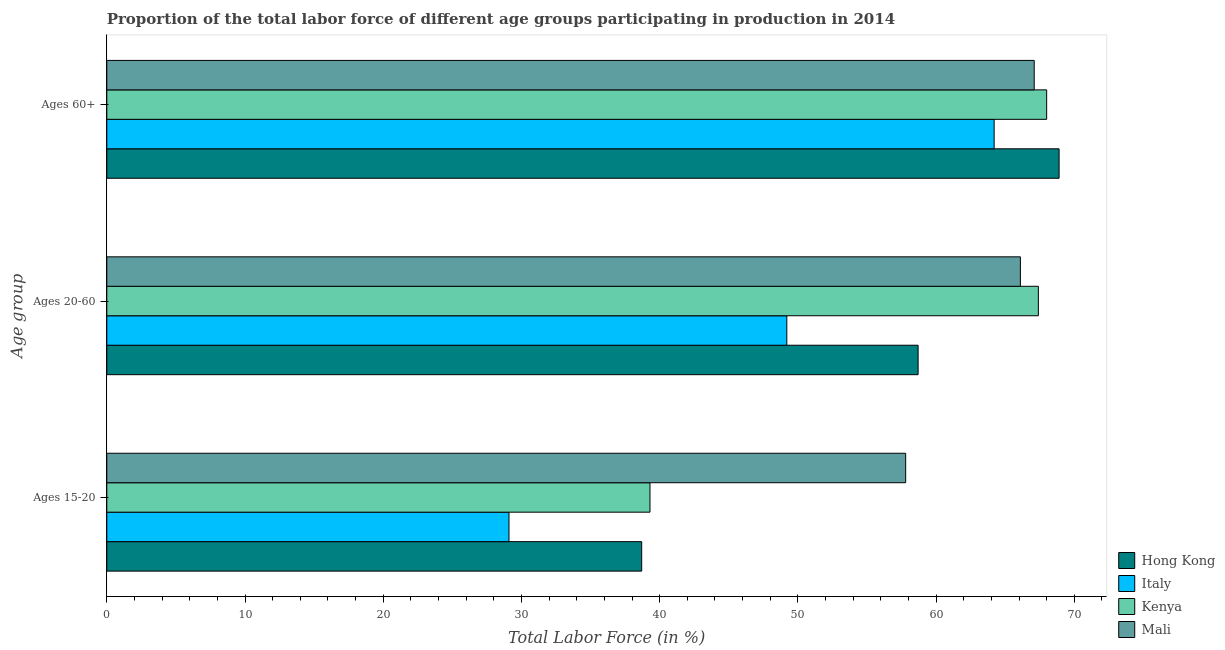How many different coloured bars are there?
Offer a very short reply. 4. How many groups of bars are there?
Your answer should be very brief. 3. Are the number of bars per tick equal to the number of legend labels?
Ensure brevity in your answer.  Yes. How many bars are there on the 2nd tick from the top?
Give a very brief answer. 4. How many bars are there on the 3rd tick from the bottom?
Your answer should be compact. 4. What is the label of the 2nd group of bars from the top?
Your answer should be very brief. Ages 20-60. What is the percentage of labor force within the age group 20-60 in Mali?
Your answer should be compact. 66.1. Across all countries, what is the maximum percentage of labor force within the age group 20-60?
Make the answer very short. 67.4. Across all countries, what is the minimum percentage of labor force above age 60?
Ensure brevity in your answer.  64.2. In which country was the percentage of labor force within the age group 20-60 maximum?
Offer a very short reply. Kenya. In which country was the percentage of labor force above age 60 minimum?
Provide a succinct answer. Italy. What is the total percentage of labor force above age 60 in the graph?
Your answer should be very brief. 268.2. What is the difference between the percentage of labor force within the age group 20-60 in Kenya and that in Italy?
Your answer should be very brief. 18.2. What is the difference between the percentage of labor force above age 60 in Mali and the percentage of labor force within the age group 15-20 in Kenya?
Offer a very short reply. 27.8. What is the average percentage of labor force above age 60 per country?
Your answer should be compact. 67.05. What is the difference between the percentage of labor force within the age group 15-20 and percentage of labor force within the age group 20-60 in Mali?
Keep it short and to the point. -8.3. In how many countries, is the percentage of labor force within the age group 20-60 greater than 4 %?
Your answer should be very brief. 4. What is the ratio of the percentage of labor force within the age group 20-60 in Mali to that in Kenya?
Provide a succinct answer. 0.98. Is the percentage of labor force within the age group 20-60 in Hong Kong less than that in Mali?
Your answer should be very brief. Yes. Is the difference between the percentage of labor force within the age group 15-20 in Hong Kong and Italy greater than the difference between the percentage of labor force above age 60 in Hong Kong and Italy?
Make the answer very short. Yes. What is the difference between the highest and the second highest percentage of labor force above age 60?
Provide a short and direct response. 0.9. What is the difference between the highest and the lowest percentage of labor force above age 60?
Offer a very short reply. 4.7. In how many countries, is the percentage of labor force within the age group 15-20 greater than the average percentage of labor force within the age group 15-20 taken over all countries?
Ensure brevity in your answer.  1. Is the sum of the percentage of labor force above age 60 in Mali and Hong Kong greater than the maximum percentage of labor force within the age group 20-60 across all countries?
Ensure brevity in your answer.  Yes. What does the 1st bar from the bottom in Ages 60+ represents?
Provide a short and direct response. Hong Kong. How many bars are there?
Make the answer very short. 12. Are all the bars in the graph horizontal?
Give a very brief answer. Yes. How many countries are there in the graph?
Provide a succinct answer. 4. Does the graph contain grids?
Ensure brevity in your answer.  No. How many legend labels are there?
Your response must be concise. 4. What is the title of the graph?
Provide a succinct answer. Proportion of the total labor force of different age groups participating in production in 2014. What is the label or title of the X-axis?
Your response must be concise. Total Labor Force (in %). What is the label or title of the Y-axis?
Ensure brevity in your answer.  Age group. What is the Total Labor Force (in %) in Hong Kong in Ages 15-20?
Offer a very short reply. 38.7. What is the Total Labor Force (in %) in Italy in Ages 15-20?
Provide a short and direct response. 29.1. What is the Total Labor Force (in %) in Kenya in Ages 15-20?
Offer a terse response. 39.3. What is the Total Labor Force (in %) in Mali in Ages 15-20?
Your answer should be very brief. 57.8. What is the Total Labor Force (in %) in Hong Kong in Ages 20-60?
Make the answer very short. 58.7. What is the Total Labor Force (in %) of Italy in Ages 20-60?
Provide a short and direct response. 49.2. What is the Total Labor Force (in %) of Kenya in Ages 20-60?
Offer a terse response. 67.4. What is the Total Labor Force (in %) of Mali in Ages 20-60?
Your answer should be compact. 66.1. What is the Total Labor Force (in %) in Hong Kong in Ages 60+?
Keep it short and to the point. 68.9. What is the Total Labor Force (in %) of Italy in Ages 60+?
Give a very brief answer. 64.2. What is the Total Labor Force (in %) of Mali in Ages 60+?
Your response must be concise. 67.1. Across all Age group, what is the maximum Total Labor Force (in %) in Hong Kong?
Make the answer very short. 68.9. Across all Age group, what is the maximum Total Labor Force (in %) of Italy?
Offer a very short reply. 64.2. Across all Age group, what is the maximum Total Labor Force (in %) in Kenya?
Your response must be concise. 68. Across all Age group, what is the maximum Total Labor Force (in %) of Mali?
Your response must be concise. 67.1. Across all Age group, what is the minimum Total Labor Force (in %) of Hong Kong?
Your response must be concise. 38.7. Across all Age group, what is the minimum Total Labor Force (in %) of Italy?
Provide a succinct answer. 29.1. Across all Age group, what is the minimum Total Labor Force (in %) of Kenya?
Provide a succinct answer. 39.3. Across all Age group, what is the minimum Total Labor Force (in %) of Mali?
Ensure brevity in your answer.  57.8. What is the total Total Labor Force (in %) of Hong Kong in the graph?
Make the answer very short. 166.3. What is the total Total Labor Force (in %) in Italy in the graph?
Your response must be concise. 142.5. What is the total Total Labor Force (in %) of Kenya in the graph?
Offer a terse response. 174.7. What is the total Total Labor Force (in %) in Mali in the graph?
Give a very brief answer. 191. What is the difference between the Total Labor Force (in %) of Italy in Ages 15-20 and that in Ages 20-60?
Give a very brief answer. -20.1. What is the difference between the Total Labor Force (in %) of Kenya in Ages 15-20 and that in Ages 20-60?
Provide a succinct answer. -28.1. What is the difference between the Total Labor Force (in %) in Hong Kong in Ages 15-20 and that in Ages 60+?
Give a very brief answer. -30.2. What is the difference between the Total Labor Force (in %) of Italy in Ages 15-20 and that in Ages 60+?
Your response must be concise. -35.1. What is the difference between the Total Labor Force (in %) in Kenya in Ages 15-20 and that in Ages 60+?
Your answer should be very brief. -28.7. What is the difference between the Total Labor Force (in %) in Hong Kong in Ages 20-60 and that in Ages 60+?
Ensure brevity in your answer.  -10.2. What is the difference between the Total Labor Force (in %) of Hong Kong in Ages 15-20 and the Total Labor Force (in %) of Italy in Ages 20-60?
Your answer should be very brief. -10.5. What is the difference between the Total Labor Force (in %) of Hong Kong in Ages 15-20 and the Total Labor Force (in %) of Kenya in Ages 20-60?
Your answer should be very brief. -28.7. What is the difference between the Total Labor Force (in %) in Hong Kong in Ages 15-20 and the Total Labor Force (in %) in Mali in Ages 20-60?
Keep it short and to the point. -27.4. What is the difference between the Total Labor Force (in %) of Italy in Ages 15-20 and the Total Labor Force (in %) of Kenya in Ages 20-60?
Provide a short and direct response. -38.3. What is the difference between the Total Labor Force (in %) of Italy in Ages 15-20 and the Total Labor Force (in %) of Mali in Ages 20-60?
Make the answer very short. -37. What is the difference between the Total Labor Force (in %) of Kenya in Ages 15-20 and the Total Labor Force (in %) of Mali in Ages 20-60?
Ensure brevity in your answer.  -26.8. What is the difference between the Total Labor Force (in %) of Hong Kong in Ages 15-20 and the Total Labor Force (in %) of Italy in Ages 60+?
Keep it short and to the point. -25.5. What is the difference between the Total Labor Force (in %) of Hong Kong in Ages 15-20 and the Total Labor Force (in %) of Kenya in Ages 60+?
Provide a succinct answer. -29.3. What is the difference between the Total Labor Force (in %) in Hong Kong in Ages 15-20 and the Total Labor Force (in %) in Mali in Ages 60+?
Keep it short and to the point. -28.4. What is the difference between the Total Labor Force (in %) of Italy in Ages 15-20 and the Total Labor Force (in %) of Kenya in Ages 60+?
Make the answer very short. -38.9. What is the difference between the Total Labor Force (in %) in Italy in Ages 15-20 and the Total Labor Force (in %) in Mali in Ages 60+?
Provide a succinct answer. -38. What is the difference between the Total Labor Force (in %) in Kenya in Ages 15-20 and the Total Labor Force (in %) in Mali in Ages 60+?
Keep it short and to the point. -27.8. What is the difference between the Total Labor Force (in %) of Hong Kong in Ages 20-60 and the Total Labor Force (in %) of Italy in Ages 60+?
Give a very brief answer. -5.5. What is the difference between the Total Labor Force (in %) of Hong Kong in Ages 20-60 and the Total Labor Force (in %) of Mali in Ages 60+?
Provide a succinct answer. -8.4. What is the difference between the Total Labor Force (in %) of Italy in Ages 20-60 and the Total Labor Force (in %) of Kenya in Ages 60+?
Offer a terse response. -18.8. What is the difference between the Total Labor Force (in %) of Italy in Ages 20-60 and the Total Labor Force (in %) of Mali in Ages 60+?
Keep it short and to the point. -17.9. What is the difference between the Total Labor Force (in %) of Kenya in Ages 20-60 and the Total Labor Force (in %) of Mali in Ages 60+?
Offer a very short reply. 0.3. What is the average Total Labor Force (in %) of Hong Kong per Age group?
Your answer should be very brief. 55.43. What is the average Total Labor Force (in %) in Italy per Age group?
Your response must be concise. 47.5. What is the average Total Labor Force (in %) of Kenya per Age group?
Offer a very short reply. 58.23. What is the average Total Labor Force (in %) in Mali per Age group?
Offer a very short reply. 63.67. What is the difference between the Total Labor Force (in %) in Hong Kong and Total Labor Force (in %) in Kenya in Ages 15-20?
Give a very brief answer. -0.6. What is the difference between the Total Labor Force (in %) of Hong Kong and Total Labor Force (in %) of Mali in Ages 15-20?
Offer a very short reply. -19.1. What is the difference between the Total Labor Force (in %) in Italy and Total Labor Force (in %) in Kenya in Ages 15-20?
Your response must be concise. -10.2. What is the difference between the Total Labor Force (in %) of Italy and Total Labor Force (in %) of Mali in Ages 15-20?
Offer a very short reply. -28.7. What is the difference between the Total Labor Force (in %) of Kenya and Total Labor Force (in %) of Mali in Ages 15-20?
Offer a terse response. -18.5. What is the difference between the Total Labor Force (in %) of Hong Kong and Total Labor Force (in %) of Italy in Ages 20-60?
Offer a terse response. 9.5. What is the difference between the Total Labor Force (in %) in Hong Kong and Total Labor Force (in %) in Kenya in Ages 20-60?
Make the answer very short. -8.7. What is the difference between the Total Labor Force (in %) in Hong Kong and Total Labor Force (in %) in Mali in Ages 20-60?
Offer a terse response. -7.4. What is the difference between the Total Labor Force (in %) in Italy and Total Labor Force (in %) in Kenya in Ages 20-60?
Provide a short and direct response. -18.2. What is the difference between the Total Labor Force (in %) of Italy and Total Labor Force (in %) of Mali in Ages 20-60?
Provide a short and direct response. -16.9. What is the difference between the Total Labor Force (in %) of Kenya and Total Labor Force (in %) of Mali in Ages 20-60?
Offer a very short reply. 1.3. What is the difference between the Total Labor Force (in %) of Hong Kong and Total Labor Force (in %) of Mali in Ages 60+?
Your answer should be very brief. 1.8. What is the difference between the Total Labor Force (in %) in Italy and Total Labor Force (in %) in Kenya in Ages 60+?
Your answer should be compact. -3.8. What is the ratio of the Total Labor Force (in %) in Hong Kong in Ages 15-20 to that in Ages 20-60?
Offer a very short reply. 0.66. What is the ratio of the Total Labor Force (in %) in Italy in Ages 15-20 to that in Ages 20-60?
Your response must be concise. 0.59. What is the ratio of the Total Labor Force (in %) in Kenya in Ages 15-20 to that in Ages 20-60?
Make the answer very short. 0.58. What is the ratio of the Total Labor Force (in %) of Mali in Ages 15-20 to that in Ages 20-60?
Make the answer very short. 0.87. What is the ratio of the Total Labor Force (in %) of Hong Kong in Ages 15-20 to that in Ages 60+?
Offer a terse response. 0.56. What is the ratio of the Total Labor Force (in %) of Italy in Ages 15-20 to that in Ages 60+?
Offer a terse response. 0.45. What is the ratio of the Total Labor Force (in %) in Kenya in Ages 15-20 to that in Ages 60+?
Offer a very short reply. 0.58. What is the ratio of the Total Labor Force (in %) in Mali in Ages 15-20 to that in Ages 60+?
Your answer should be very brief. 0.86. What is the ratio of the Total Labor Force (in %) in Hong Kong in Ages 20-60 to that in Ages 60+?
Offer a very short reply. 0.85. What is the ratio of the Total Labor Force (in %) in Italy in Ages 20-60 to that in Ages 60+?
Your answer should be very brief. 0.77. What is the ratio of the Total Labor Force (in %) in Kenya in Ages 20-60 to that in Ages 60+?
Give a very brief answer. 0.99. What is the ratio of the Total Labor Force (in %) in Mali in Ages 20-60 to that in Ages 60+?
Provide a succinct answer. 0.99. What is the difference between the highest and the second highest Total Labor Force (in %) in Hong Kong?
Offer a very short reply. 10.2. What is the difference between the highest and the second highest Total Labor Force (in %) in Mali?
Offer a terse response. 1. What is the difference between the highest and the lowest Total Labor Force (in %) of Hong Kong?
Provide a short and direct response. 30.2. What is the difference between the highest and the lowest Total Labor Force (in %) of Italy?
Offer a very short reply. 35.1. What is the difference between the highest and the lowest Total Labor Force (in %) in Kenya?
Make the answer very short. 28.7. What is the difference between the highest and the lowest Total Labor Force (in %) of Mali?
Offer a terse response. 9.3. 